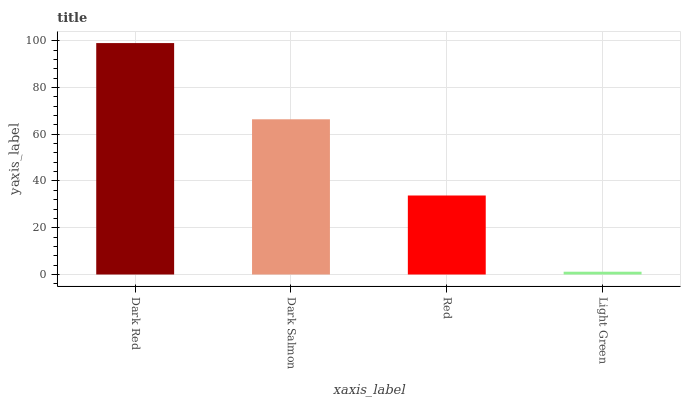Is Light Green the minimum?
Answer yes or no. Yes. Is Dark Red the maximum?
Answer yes or no. Yes. Is Dark Salmon the minimum?
Answer yes or no. No. Is Dark Salmon the maximum?
Answer yes or no. No. Is Dark Red greater than Dark Salmon?
Answer yes or no. Yes. Is Dark Salmon less than Dark Red?
Answer yes or no. Yes. Is Dark Salmon greater than Dark Red?
Answer yes or no. No. Is Dark Red less than Dark Salmon?
Answer yes or no. No. Is Dark Salmon the high median?
Answer yes or no. Yes. Is Red the low median?
Answer yes or no. Yes. Is Light Green the high median?
Answer yes or no. No. Is Dark Salmon the low median?
Answer yes or no. No. 